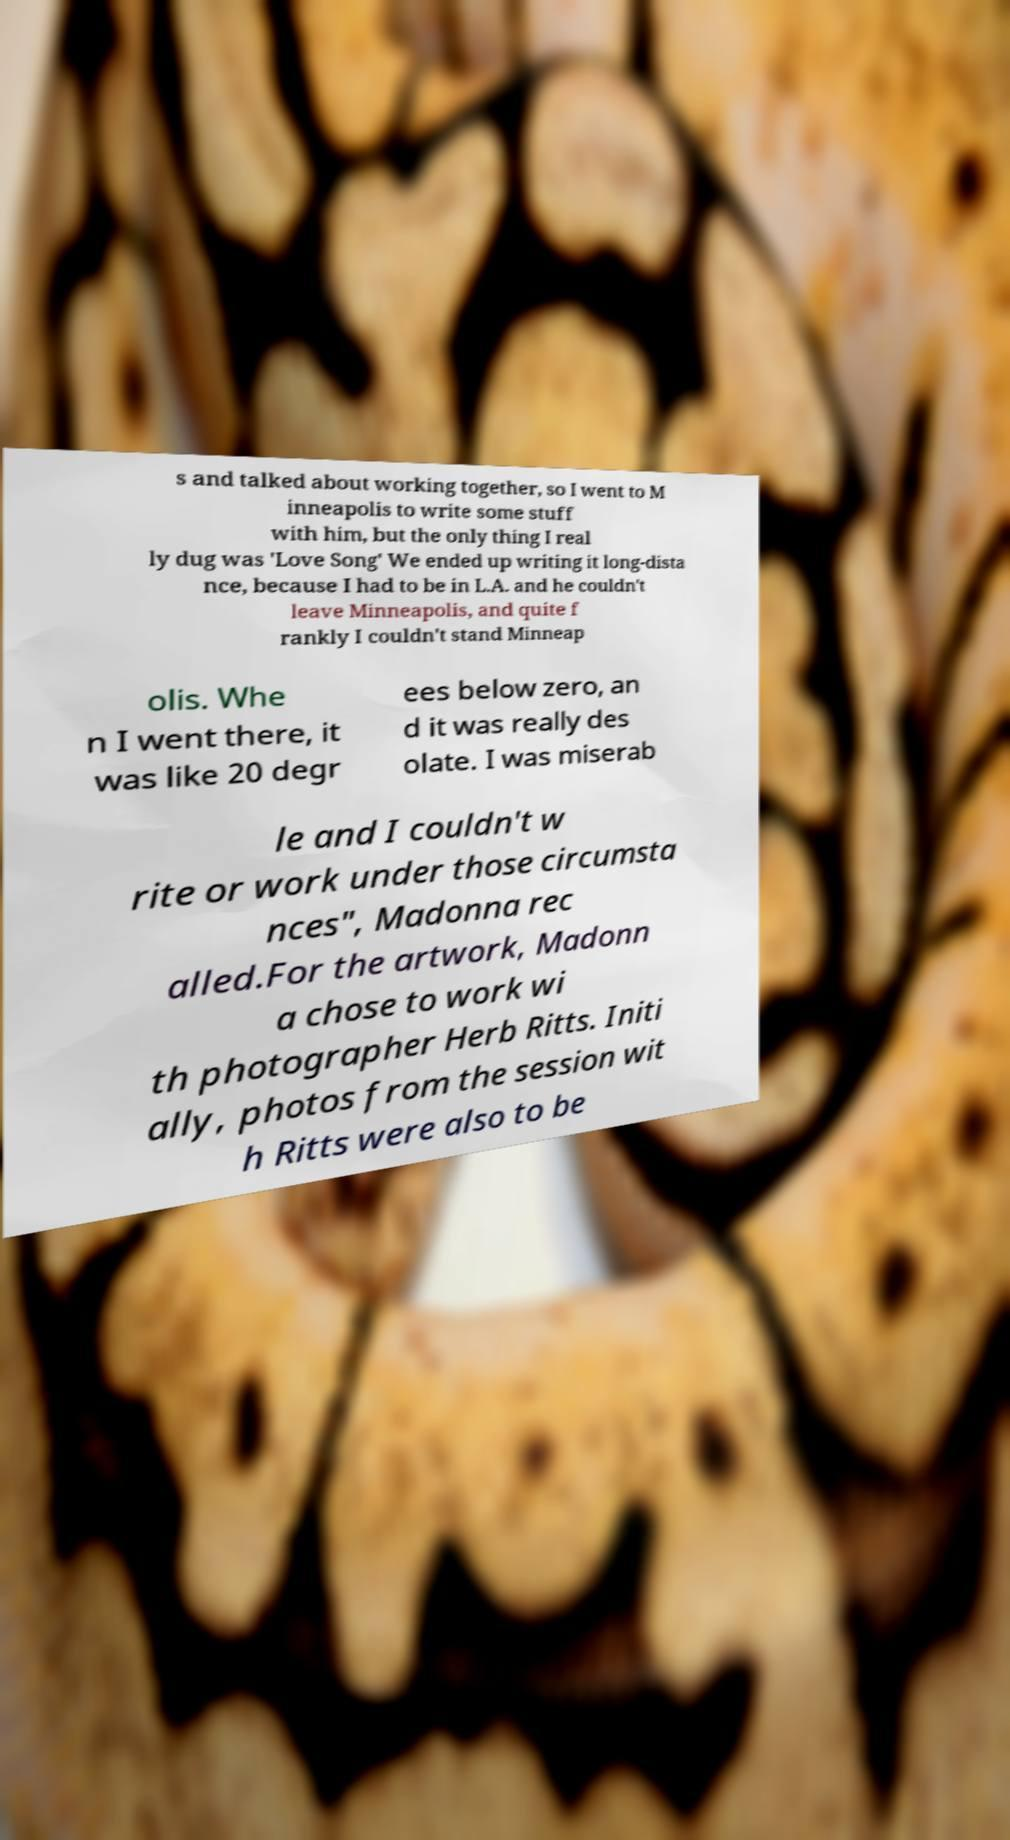Can you accurately transcribe the text from the provided image for me? s and talked about working together, so I went to M inneapolis to write some stuff with him, but the only thing I real ly dug was 'Love Song' We ended up writing it long-dista nce, because I had to be in L.A. and he couldn't leave Minneapolis, and quite f rankly I couldn't stand Minneap olis. Whe n I went there, it was like 20 degr ees below zero, an d it was really des olate. I was miserab le and I couldn't w rite or work under those circumsta nces", Madonna rec alled.For the artwork, Madonn a chose to work wi th photographer Herb Ritts. Initi ally, photos from the session wit h Ritts were also to be 